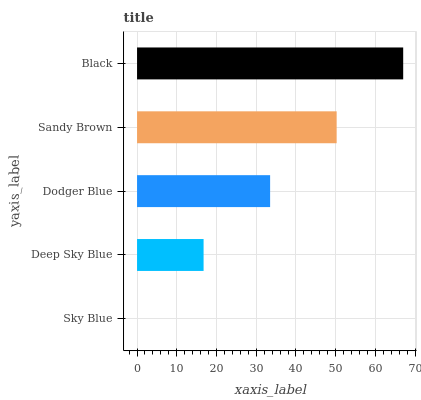Is Sky Blue the minimum?
Answer yes or no. Yes. Is Black the maximum?
Answer yes or no. Yes. Is Deep Sky Blue the minimum?
Answer yes or no. No. Is Deep Sky Blue the maximum?
Answer yes or no. No. Is Deep Sky Blue greater than Sky Blue?
Answer yes or no. Yes. Is Sky Blue less than Deep Sky Blue?
Answer yes or no. Yes. Is Sky Blue greater than Deep Sky Blue?
Answer yes or no. No. Is Deep Sky Blue less than Sky Blue?
Answer yes or no. No. Is Dodger Blue the high median?
Answer yes or no. Yes. Is Dodger Blue the low median?
Answer yes or no. Yes. Is Black the high median?
Answer yes or no. No. Is Sandy Brown the low median?
Answer yes or no. No. 